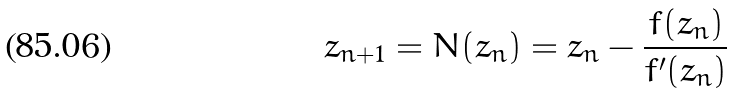<formula> <loc_0><loc_0><loc_500><loc_500>z _ { n + 1 } = N ( z _ { n } ) = z _ { n } - \frac { f ( z _ { n } ) } { f ^ { \prime } ( z _ { n } ) }</formula> 